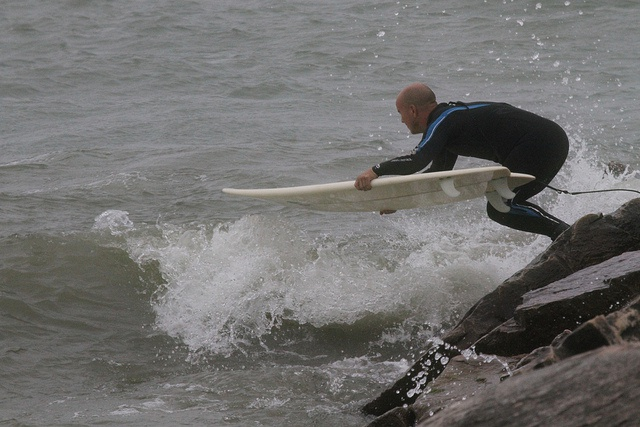Describe the objects in this image and their specific colors. I can see people in gray, black, and maroon tones and surfboard in gray and darkgray tones in this image. 